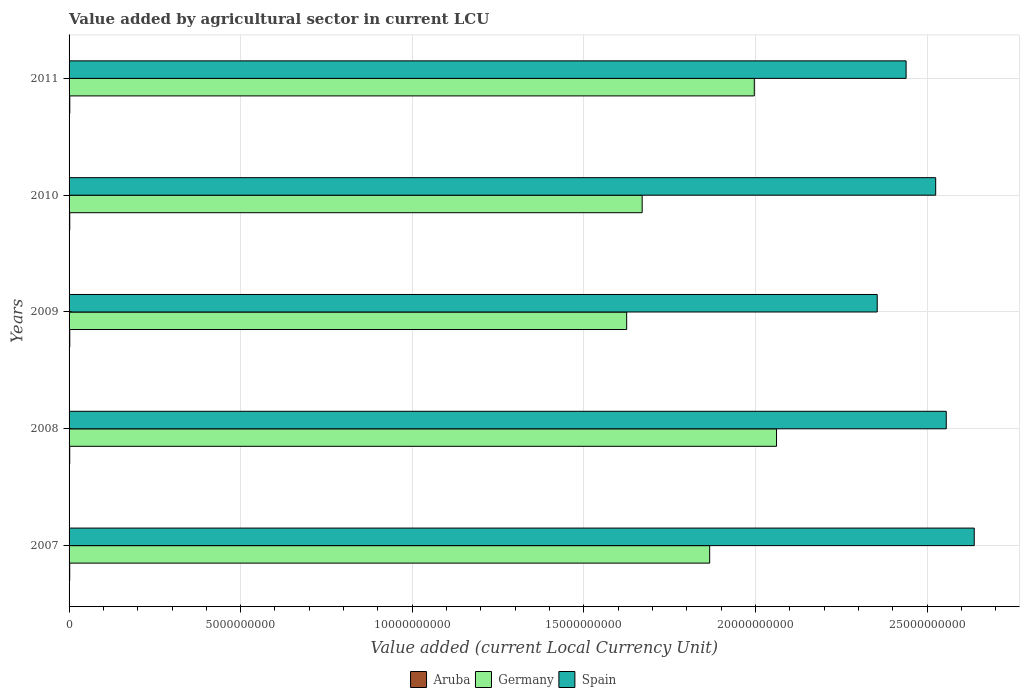Are the number of bars on each tick of the Y-axis equal?
Keep it short and to the point. Yes. How many bars are there on the 4th tick from the top?
Provide a succinct answer. 3. How many bars are there on the 1st tick from the bottom?
Make the answer very short. 3. What is the value added by agricultural sector in Germany in 2010?
Provide a succinct answer. 1.67e+1. Across all years, what is the maximum value added by agricultural sector in Aruba?
Provide a short and direct response. 2.12e+07. Across all years, what is the minimum value added by agricultural sector in Aruba?
Keep it short and to the point. 1.89e+07. What is the total value added by agricultural sector in Aruba in the graph?
Your answer should be compact. 9.91e+07. What is the difference between the value added by agricultural sector in Aruba in 2007 and that in 2011?
Make the answer very short. -2.38e+06. What is the difference between the value added by agricultural sector in Spain in 2010 and the value added by agricultural sector in Aruba in 2009?
Your answer should be very brief. 2.52e+1. What is the average value added by agricultural sector in Aruba per year?
Your response must be concise. 1.98e+07. In the year 2009, what is the difference between the value added by agricultural sector in Aruba and value added by agricultural sector in Spain?
Your response must be concise. -2.35e+1. What is the ratio of the value added by agricultural sector in Spain in 2010 to that in 2011?
Offer a very short reply. 1.04. Is the value added by agricultural sector in Aruba in 2007 less than that in 2008?
Make the answer very short. Yes. Is the difference between the value added by agricultural sector in Aruba in 2007 and 2011 greater than the difference between the value added by agricultural sector in Spain in 2007 and 2011?
Make the answer very short. No. What is the difference between the highest and the second highest value added by agricultural sector in Germany?
Ensure brevity in your answer.  6.48e+08. What is the difference between the highest and the lowest value added by agricultural sector in Germany?
Offer a terse response. 4.37e+09. Is the sum of the value added by agricultural sector in Germany in 2009 and 2011 greater than the maximum value added by agricultural sector in Aruba across all years?
Make the answer very short. Yes. What does the 2nd bar from the bottom in 2010 represents?
Provide a succinct answer. Germany. Is it the case that in every year, the sum of the value added by agricultural sector in Aruba and value added by agricultural sector in Spain is greater than the value added by agricultural sector in Germany?
Make the answer very short. Yes. How many bars are there?
Make the answer very short. 15. Are all the bars in the graph horizontal?
Provide a succinct answer. Yes. Are the values on the major ticks of X-axis written in scientific E-notation?
Your answer should be compact. No. Does the graph contain any zero values?
Make the answer very short. No. Does the graph contain grids?
Offer a very short reply. Yes. What is the title of the graph?
Offer a very short reply. Value added by agricultural sector in current LCU. Does "World" appear as one of the legend labels in the graph?
Give a very brief answer. No. What is the label or title of the X-axis?
Your answer should be very brief. Value added (current Local Currency Unit). What is the Value added (current Local Currency Unit) of Aruba in 2007?
Make the answer very short. 1.89e+07. What is the Value added (current Local Currency Unit) in Germany in 2007?
Keep it short and to the point. 1.87e+1. What is the Value added (current Local Currency Unit) in Spain in 2007?
Your answer should be compact. 2.64e+1. What is the Value added (current Local Currency Unit) in Aruba in 2008?
Your answer should be compact. 1.91e+07. What is the Value added (current Local Currency Unit) of Germany in 2008?
Offer a very short reply. 2.06e+1. What is the Value added (current Local Currency Unit) in Spain in 2008?
Ensure brevity in your answer.  2.56e+1. What is the Value added (current Local Currency Unit) in Aruba in 2009?
Offer a very short reply. 2.01e+07. What is the Value added (current Local Currency Unit) in Germany in 2009?
Make the answer very short. 1.62e+1. What is the Value added (current Local Currency Unit) in Spain in 2009?
Ensure brevity in your answer.  2.35e+1. What is the Value added (current Local Currency Unit) of Aruba in 2010?
Offer a very short reply. 1.98e+07. What is the Value added (current Local Currency Unit) of Germany in 2010?
Give a very brief answer. 1.67e+1. What is the Value added (current Local Currency Unit) in Spain in 2010?
Your answer should be very brief. 2.53e+1. What is the Value added (current Local Currency Unit) of Aruba in 2011?
Offer a very short reply. 2.12e+07. What is the Value added (current Local Currency Unit) in Germany in 2011?
Keep it short and to the point. 2.00e+1. What is the Value added (current Local Currency Unit) in Spain in 2011?
Offer a very short reply. 2.44e+1. Across all years, what is the maximum Value added (current Local Currency Unit) in Aruba?
Your answer should be compact. 2.12e+07. Across all years, what is the maximum Value added (current Local Currency Unit) in Germany?
Ensure brevity in your answer.  2.06e+1. Across all years, what is the maximum Value added (current Local Currency Unit) of Spain?
Provide a short and direct response. 2.64e+1. Across all years, what is the minimum Value added (current Local Currency Unit) of Aruba?
Give a very brief answer. 1.89e+07. Across all years, what is the minimum Value added (current Local Currency Unit) of Germany?
Your response must be concise. 1.62e+1. Across all years, what is the minimum Value added (current Local Currency Unit) in Spain?
Your answer should be very brief. 2.35e+1. What is the total Value added (current Local Currency Unit) in Aruba in the graph?
Give a very brief answer. 9.91e+07. What is the total Value added (current Local Currency Unit) of Germany in the graph?
Provide a short and direct response. 9.22e+1. What is the total Value added (current Local Currency Unit) of Spain in the graph?
Provide a short and direct response. 1.25e+11. What is the difference between the Value added (current Local Currency Unit) in Germany in 2007 and that in 2008?
Your answer should be compact. -1.95e+09. What is the difference between the Value added (current Local Currency Unit) of Spain in 2007 and that in 2008?
Offer a terse response. 8.15e+08. What is the difference between the Value added (current Local Currency Unit) of Aruba in 2007 and that in 2009?
Make the answer very short. -1.20e+06. What is the difference between the Value added (current Local Currency Unit) of Germany in 2007 and that in 2009?
Provide a succinct answer. 2.42e+09. What is the difference between the Value added (current Local Currency Unit) in Spain in 2007 and that in 2009?
Your answer should be compact. 2.83e+09. What is the difference between the Value added (current Local Currency Unit) in Aruba in 2007 and that in 2010?
Ensure brevity in your answer.  -9.90e+05. What is the difference between the Value added (current Local Currency Unit) of Germany in 2007 and that in 2010?
Keep it short and to the point. 1.97e+09. What is the difference between the Value added (current Local Currency Unit) of Spain in 2007 and that in 2010?
Your answer should be compact. 1.12e+09. What is the difference between the Value added (current Local Currency Unit) in Aruba in 2007 and that in 2011?
Ensure brevity in your answer.  -2.38e+06. What is the difference between the Value added (current Local Currency Unit) of Germany in 2007 and that in 2011?
Offer a terse response. -1.30e+09. What is the difference between the Value added (current Local Currency Unit) of Spain in 2007 and that in 2011?
Keep it short and to the point. 1.98e+09. What is the difference between the Value added (current Local Currency Unit) of Aruba in 2008 and that in 2009?
Provide a short and direct response. -9.90e+05. What is the difference between the Value added (current Local Currency Unit) of Germany in 2008 and that in 2009?
Ensure brevity in your answer.  4.37e+09. What is the difference between the Value added (current Local Currency Unit) of Spain in 2008 and that in 2009?
Provide a succinct answer. 2.01e+09. What is the difference between the Value added (current Local Currency Unit) of Aruba in 2008 and that in 2010?
Provide a succinct answer. -7.80e+05. What is the difference between the Value added (current Local Currency Unit) of Germany in 2008 and that in 2010?
Your answer should be very brief. 3.92e+09. What is the difference between the Value added (current Local Currency Unit) of Spain in 2008 and that in 2010?
Your answer should be compact. 3.08e+08. What is the difference between the Value added (current Local Currency Unit) of Aruba in 2008 and that in 2011?
Make the answer very short. -2.17e+06. What is the difference between the Value added (current Local Currency Unit) in Germany in 2008 and that in 2011?
Make the answer very short. 6.48e+08. What is the difference between the Value added (current Local Currency Unit) in Spain in 2008 and that in 2011?
Your answer should be very brief. 1.17e+09. What is the difference between the Value added (current Local Currency Unit) in Aruba in 2009 and that in 2010?
Your answer should be very brief. 2.10e+05. What is the difference between the Value added (current Local Currency Unit) of Germany in 2009 and that in 2010?
Provide a succinct answer. -4.52e+08. What is the difference between the Value added (current Local Currency Unit) of Spain in 2009 and that in 2010?
Keep it short and to the point. -1.70e+09. What is the difference between the Value added (current Local Currency Unit) in Aruba in 2009 and that in 2011?
Your answer should be compact. -1.18e+06. What is the difference between the Value added (current Local Currency Unit) in Germany in 2009 and that in 2011?
Offer a very short reply. -3.72e+09. What is the difference between the Value added (current Local Currency Unit) in Spain in 2009 and that in 2011?
Your answer should be very brief. -8.42e+08. What is the difference between the Value added (current Local Currency Unit) of Aruba in 2010 and that in 2011?
Your answer should be very brief. -1.39e+06. What is the difference between the Value added (current Local Currency Unit) of Germany in 2010 and that in 2011?
Keep it short and to the point. -3.27e+09. What is the difference between the Value added (current Local Currency Unit) of Spain in 2010 and that in 2011?
Give a very brief answer. 8.62e+08. What is the difference between the Value added (current Local Currency Unit) in Aruba in 2007 and the Value added (current Local Currency Unit) in Germany in 2008?
Offer a terse response. -2.06e+1. What is the difference between the Value added (current Local Currency Unit) in Aruba in 2007 and the Value added (current Local Currency Unit) in Spain in 2008?
Offer a very short reply. -2.55e+1. What is the difference between the Value added (current Local Currency Unit) of Germany in 2007 and the Value added (current Local Currency Unit) of Spain in 2008?
Give a very brief answer. -6.89e+09. What is the difference between the Value added (current Local Currency Unit) in Aruba in 2007 and the Value added (current Local Currency Unit) in Germany in 2009?
Ensure brevity in your answer.  -1.62e+1. What is the difference between the Value added (current Local Currency Unit) in Aruba in 2007 and the Value added (current Local Currency Unit) in Spain in 2009?
Keep it short and to the point. -2.35e+1. What is the difference between the Value added (current Local Currency Unit) in Germany in 2007 and the Value added (current Local Currency Unit) in Spain in 2009?
Provide a succinct answer. -4.88e+09. What is the difference between the Value added (current Local Currency Unit) in Aruba in 2007 and the Value added (current Local Currency Unit) in Germany in 2010?
Offer a terse response. -1.67e+1. What is the difference between the Value added (current Local Currency Unit) in Aruba in 2007 and the Value added (current Local Currency Unit) in Spain in 2010?
Your response must be concise. -2.52e+1. What is the difference between the Value added (current Local Currency Unit) in Germany in 2007 and the Value added (current Local Currency Unit) in Spain in 2010?
Ensure brevity in your answer.  -6.59e+09. What is the difference between the Value added (current Local Currency Unit) of Aruba in 2007 and the Value added (current Local Currency Unit) of Germany in 2011?
Your response must be concise. -1.99e+1. What is the difference between the Value added (current Local Currency Unit) of Aruba in 2007 and the Value added (current Local Currency Unit) of Spain in 2011?
Ensure brevity in your answer.  -2.44e+1. What is the difference between the Value added (current Local Currency Unit) in Germany in 2007 and the Value added (current Local Currency Unit) in Spain in 2011?
Your answer should be compact. -5.72e+09. What is the difference between the Value added (current Local Currency Unit) of Aruba in 2008 and the Value added (current Local Currency Unit) of Germany in 2009?
Make the answer very short. -1.62e+1. What is the difference between the Value added (current Local Currency Unit) in Aruba in 2008 and the Value added (current Local Currency Unit) in Spain in 2009?
Provide a short and direct response. -2.35e+1. What is the difference between the Value added (current Local Currency Unit) of Germany in 2008 and the Value added (current Local Currency Unit) of Spain in 2009?
Your response must be concise. -2.93e+09. What is the difference between the Value added (current Local Currency Unit) of Aruba in 2008 and the Value added (current Local Currency Unit) of Germany in 2010?
Your answer should be very brief. -1.67e+1. What is the difference between the Value added (current Local Currency Unit) of Aruba in 2008 and the Value added (current Local Currency Unit) of Spain in 2010?
Keep it short and to the point. -2.52e+1. What is the difference between the Value added (current Local Currency Unit) of Germany in 2008 and the Value added (current Local Currency Unit) of Spain in 2010?
Give a very brief answer. -4.64e+09. What is the difference between the Value added (current Local Currency Unit) in Aruba in 2008 and the Value added (current Local Currency Unit) in Germany in 2011?
Provide a short and direct response. -1.99e+1. What is the difference between the Value added (current Local Currency Unit) of Aruba in 2008 and the Value added (current Local Currency Unit) of Spain in 2011?
Provide a short and direct response. -2.44e+1. What is the difference between the Value added (current Local Currency Unit) of Germany in 2008 and the Value added (current Local Currency Unit) of Spain in 2011?
Give a very brief answer. -3.78e+09. What is the difference between the Value added (current Local Currency Unit) of Aruba in 2009 and the Value added (current Local Currency Unit) of Germany in 2010?
Provide a succinct answer. -1.67e+1. What is the difference between the Value added (current Local Currency Unit) of Aruba in 2009 and the Value added (current Local Currency Unit) of Spain in 2010?
Keep it short and to the point. -2.52e+1. What is the difference between the Value added (current Local Currency Unit) in Germany in 2009 and the Value added (current Local Currency Unit) in Spain in 2010?
Offer a terse response. -9.00e+09. What is the difference between the Value added (current Local Currency Unit) of Aruba in 2009 and the Value added (current Local Currency Unit) of Germany in 2011?
Offer a terse response. -1.99e+1. What is the difference between the Value added (current Local Currency Unit) in Aruba in 2009 and the Value added (current Local Currency Unit) in Spain in 2011?
Provide a succinct answer. -2.44e+1. What is the difference between the Value added (current Local Currency Unit) of Germany in 2009 and the Value added (current Local Currency Unit) of Spain in 2011?
Ensure brevity in your answer.  -8.14e+09. What is the difference between the Value added (current Local Currency Unit) of Aruba in 2010 and the Value added (current Local Currency Unit) of Germany in 2011?
Make the answer very short. -1.99e+1. What is the difference between the Value added (current Local Currency Unit) of Aruba in 2010 and the Value added (current Local Currency Unit) of Spain in 2011?
Your answer should be compact. -2.44e+1. What is the difference between the Value added (current Local Currency Unit) of Germany in 2010 and the Value added (current Local Currency Unit) of Spain in 2011?
Keep it short and to the point. -7.69e+09. What is the average Value added (current Local Currency Unit) in Aruba per year?
Give a very brief answer. 1.98e+07. What is the average Value added (current Local Currency Unit) of Germany per year?
Ensure brevity in your answer.  1.84e+1. What is the average Value added (current Local Currency Unit) of Spain per year?
Offer a very short reply. 2.50e+1. In the year 2007, what is the difference between the Value added (current Local Currency Unit) in Aruba and Value added (current Local Currency Unit) in Germany?
Provide a short and direct response. -1.86e+1. In the year 2007, what is the difference between the Value added (current Local Currency Unit) in Aruba and Value added (current Local Currency Unit) in Spain?
Make the answer very short. -2.64e+1. In the year 2007, what is the difference between the Value added (current Local Currency Unit) in Germany and Value added (current Local Currency Unit) in Spain?
Provide a short and direct response. -7.71e+09. In the year 2008, what is the difference between the Value added (current Local Currency Unit) in Aruba and Value added (current Local Currency Unit) in Germany?
Offer a terse response. -2.06e+1. In the year 2008, what is the difference between the Value added (current Local Currency Unit) in Aruba and Value added (current Local Currency Unit) in Spain?
Give a very brief answer. -2.55e+1. In the year 2008, what is the difference between the Value added (current Local Currency Unit) in Germany and Value added (current Local Currency Unit) in Spain?
Your answer should be compact. -4.95e+09. In the year 2009, what is the difference between the Value added (current Local Currency Unit) in Aruba and Value added (current Local Currency Unit) in Germany?
Make the answer very short. -1.62e+1. In the year 2009, what is the difference between the Value added (current Local Currency Unit) of Aruba and Value added (current Local Currency Unit) of Spain?
Provide a succinct answer. -2.35e+1. In the year 2009, what is the difference between the Value added (current Local Currency Unit) in Germany and Value added (current Local Currency Unit) in Spain?
Make the answer very short. -7.30e+09. In the year 2010, what is the difference between the Value added (current Local Currency Unit) in Aruba and Value added (current Local Currency Unit) in Germany?
Give a very brief answer. -1.67e+1. In the year 2010, what is the difference between the Value added (current Local Currency Unit) in Aruba and Value added (current Local Currency Unit) in Spain?
Offer a very short reply. -2.52e+1. In the year 2010, what is the difference between the Value added (current Local Currency Unit) of Germany and Value added (current Local Currency Unit) of Spain?
Keep it short and to the point. -8.55e+09. In the year 2011, what is the difference between the Value added (current Local Currency Unit) of Aruba and Value added (current Local Currency Unit) of Germany?
Your response must be concise. -1.99e+1. In the year 2011, what is the difference between the Value added (current Local Currency Unit) of Aruba and Value added (current Local Currency Unit) of Spain?
Offer a terse response. -2.44e+1. In the year 2011, what is the difference between the Value added (current Local Currency Unit) in Germany and Value added (current Local Currency Unit) in Spain?
Make the answer very short. -4.42e+09. What is the ratio of the Value added (current Local Currency Unit) of Germany in 2007 to that in 2008?
Make the answer very short. 0.91. What is the ratio of the Value added (current Local Currency Unit) in Spain in 2007 to that in 2008?
Your answer should be compact. 1.03. What is the ratio of the Value added (current Local Currency Unit) in Aruba in 2007 to that in 2009?
Offer a terse response. 0.94. What is the ratio of the Value added (current Local Currency Unit) of Germany in 2007 to that in 2009?
Keep it short and to the point. 1.15. What is the ratio of the Value added (current Local Currency Unit) in Spain in 2007 to that in 2009?
Your answer should be very brief. 1.12. What is the ratio of the Value added (current Local Currency Unit) of Aruba in 2007 to that in 2010?
Your answer should be compact. 0.95. What is the ratio of the Value added (current Local Currency Unit) in Germany in 2007 to that in 2010?
Ensure brevity in your answer.  1.12. What is the ratio of the Value added (current Local Currency Unit) in Spain in 2007 to that in 2010?
Offer a terse response. 1.04. What is the ratio of the Value added (current Local Currency Unit) of Aruba in 2007 to that in 2011?
Provide a short and direct response. 0.89. What is the ratio of the Value added (current Local Currency Unit) of Germany in 2007 to that in 2011?
Keep it short and to the point. 0.93. What is the ratio of the Value added (current Local Currency Unit) of Spain in 2007 to that in 2011?
Provide a succinct answer. 1.08. What is the ratio of the Value added (current Local Currency Unit) in Aruba in 2008 to that in 2009?
Your answer should be very brief. 0.95. What is the ratio of the Value added (current Local Currency Unit) in Germany in 2008 to that in 2009?
Offer a very short reply. 1.27. What is the ratio of the Value added (current Local Currency Unit) of Spain in 2008 to that in 2009?
Make the answer very short. 1.09. What is the ratio of the Value added (current Local Currency Unit) of Aruba in 2008 to that in 2010?
Give a very brief answer. 0.96. What is the ratio of the Value added (current Local Currency Unit) in Germany in 2008 to that in 2010?
Give a very brief answer. 1.23. What is the ratio of the Value added (current Local Currency Unit) of Spain in 2008 to that in 2010?
Provide a short and direct response. 1.01. What is the ratio of the Value added (current Local Currency Unit) of Aruba in 2008 to that in 2011?
Offer a terse response. 0.9. What is the ratio of the Value added (current Local Currency Unit) in Germany in 2008 to that in 2011?
Offer a very short reply. 1.03. What is the ratio of the Value added (current Local Currency Unit) of Spain in 2008 to that in 2011?
Your response must be concise. 1.05. What is the ratio of the Value added (current Local Currency Unit) in Aruba in 2009 to that in 2010?
Keep it short and to the point. 1.01. What is the ratio of the Value added (current Local Currency Unit) in Germany in 2009 to that in 2010?
Make the answer very short. 0.97. What is the ratio of the Value added (current Local Currency Unit) in Spain in 2009 to that in 2010?
Offer a very short reply. 0.93. What is the ratio of the Value added (current Local Currency Unit) of Germany in 2009 to that in 2011?
Provide a short and direct response. 0.81. What is the ratio of the Value added (current Local Currency Unit) in Spain in 2009 to that in 2011?
Offer a terse response. 0.97. What is the ratio of the Value added (current Local Currency Unit) of Aruba in 2010 to that in 2011?
Your response must be concise. 0.93. What is the ratio of the Value added (current Local Currency Unit) of Germany in 2010 to that in 2011?
Make the answer very short. 0.84. What is the ratio of the Value added (current Local Currency Unit) of Spain in 2010 to that in 2011?
Your answer should be very brief. 1.04. What is the difference between the highest and the second highest Value added (current Local Currency Unit) in Aruba?
Your answer should be compact. 1.18e+06. What is the difference between the highest and the second highest Value added (current Local Currency Unit) in Germany?
Your response must be concise. 6.48e+08. What is the difference between the highest and the second highest Value added (current Local Currency Unit) of Spain?
Ensure brevity in your answer.  8.15e+08. What is the difference between the highest and the lowest Value added (current Local Currency Unit) of Aruba?
Offer a very short reply. 2.38e+06. What is the difference between the highest and the lowest Value added (current Local Currency Unit) of Germany?
Make the answer very short. 4.37e+09. What is the difference between the highest and the lowest Value added (current Local Currency Unit) in Spain?
Make the answer very short. 2.83e+09. 